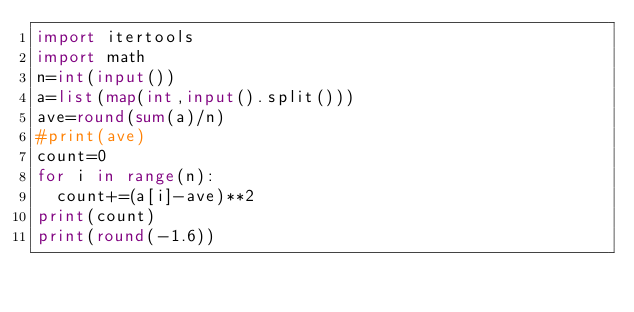Convert code to text. <code><loc_0><loc_0><loc_500><loc_500><_Python_>import itertools
import math
n=int(input())
a=list(map(int,input().split()))
ave=round(sum(a)/n)
#print(ave)
count=0
for i in range(n):
	count+=(a[i]-ave)**2
print(count)
print(round(-1.6))
</code> 